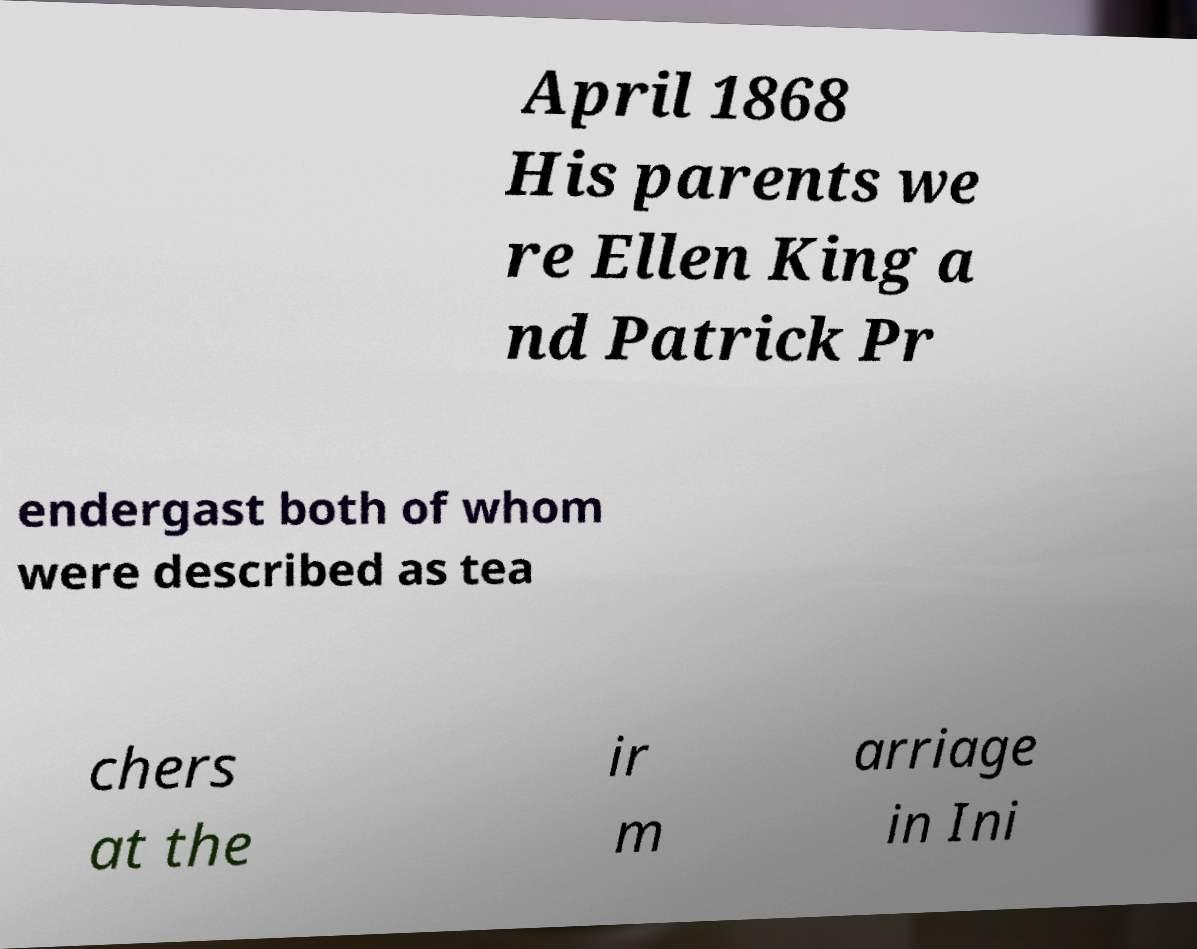Can you accurately transcribe the text from the provided image for me? April 1868 His parents we re Ellen King a nd Patrick Pr endergast both of whom were described as tea chers at the ir m arriage in Ini 